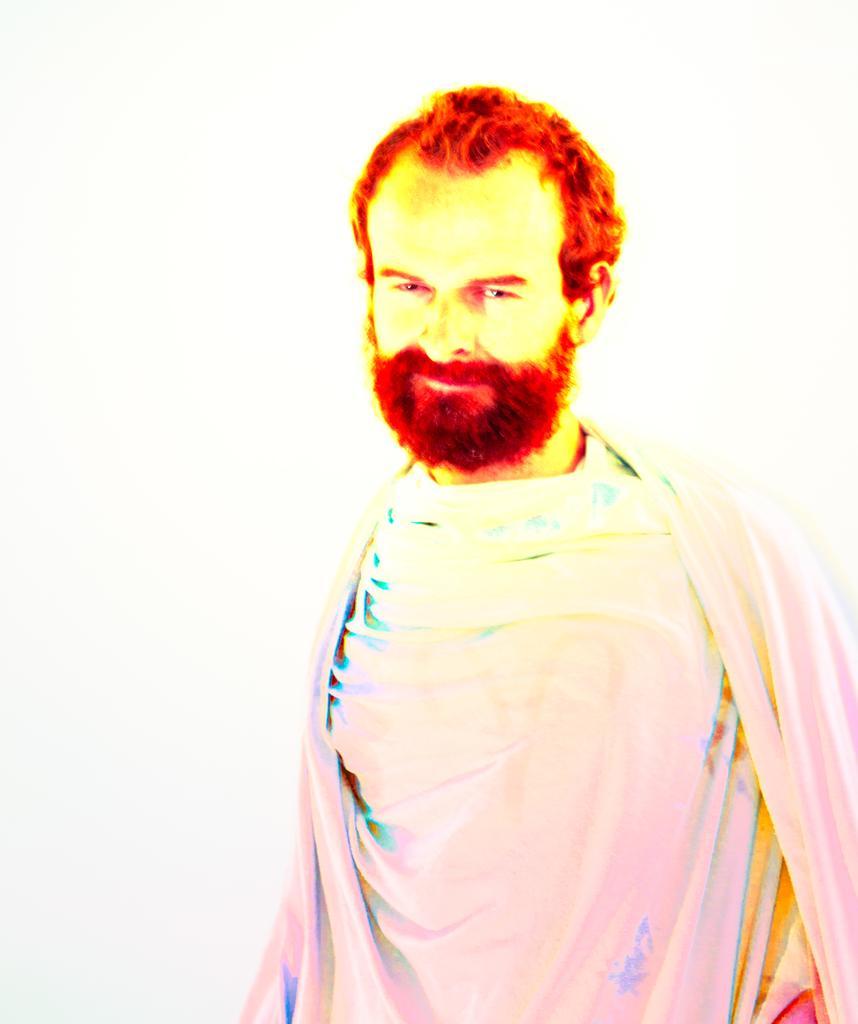Can you describe this image briefly? In this picture we can see a man and in the background it is in white color. 